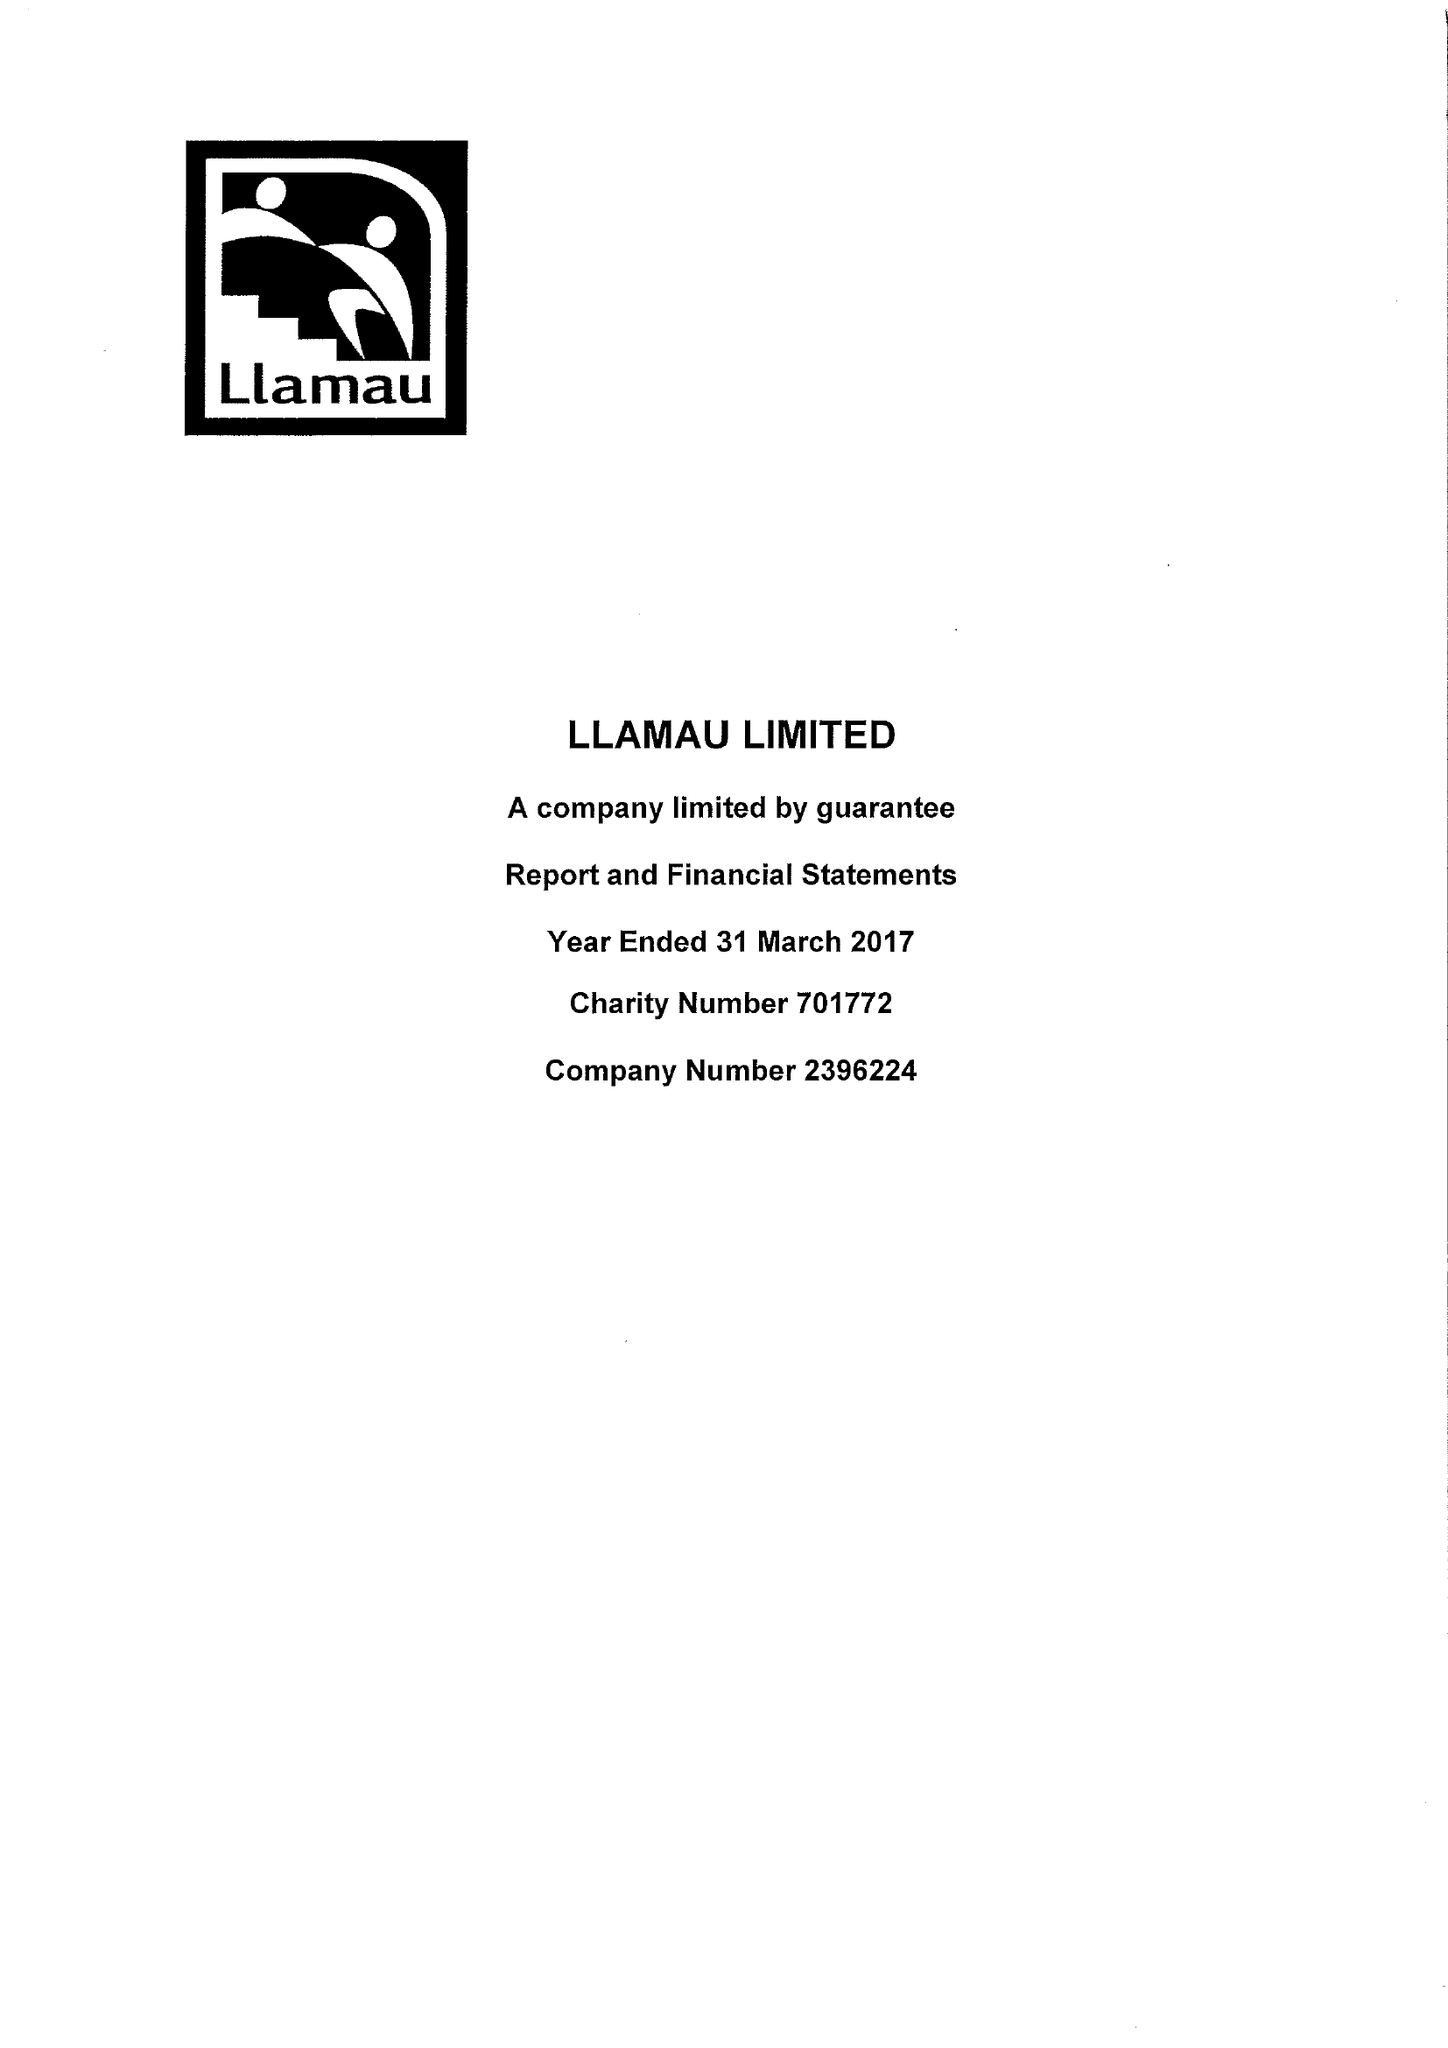What is the value for the address__street_line?
Answer the question using a single word or phrase. 23-25 CATHEDRAL ROAD 